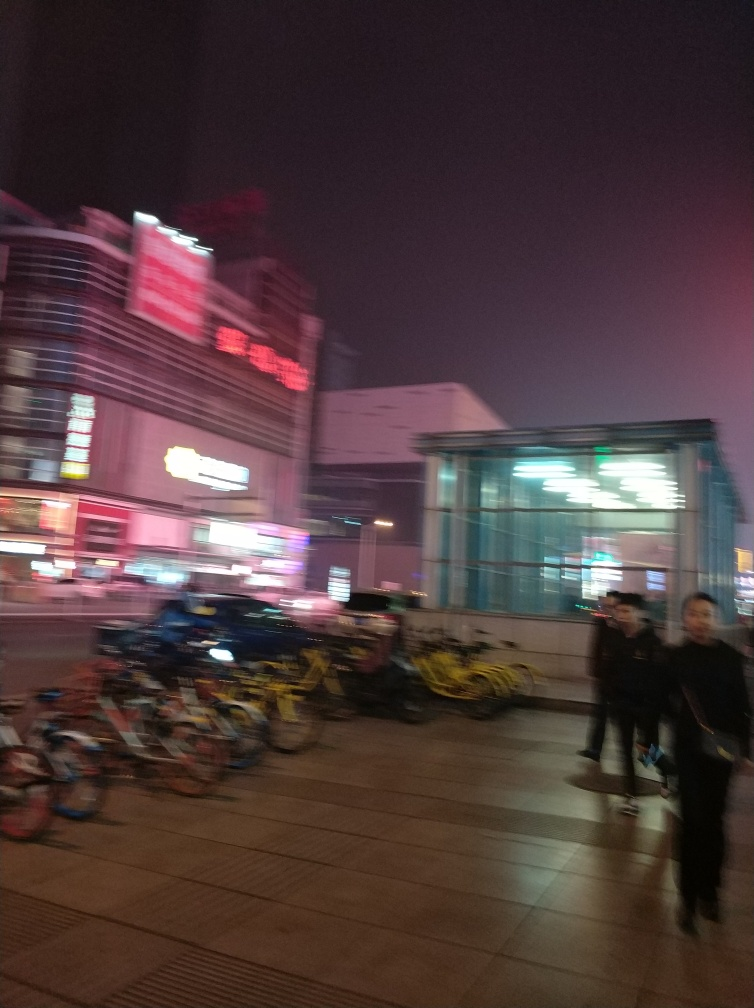What time of day does this photo appear to have been taken? The photo seems to have been taken in the evening or at night, judging by the artificial lighting and the darkness of the sky. 